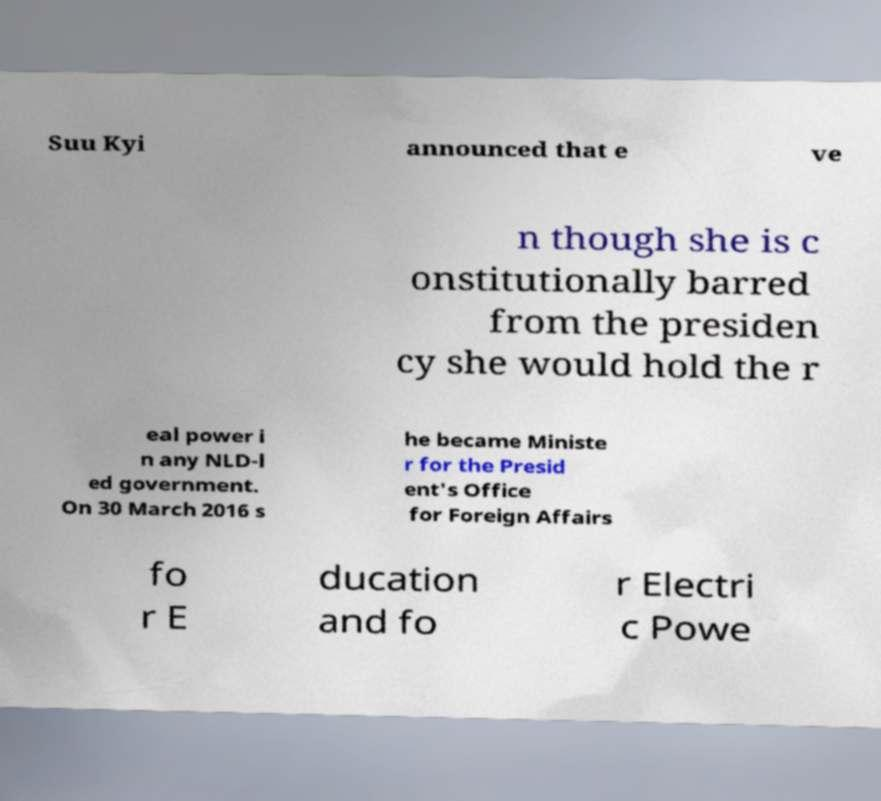Could you assist in decoding the text presented in this image and type it out clearly? Suu Kyi announced that e ve n though she is c onstitutionally barred from the presiden cy she would hold the r eal power i n any NLD-l ed government. On 30 March 2016 s he became Ministe r for the Presid ent's Office for Foreign Affairs fo r E ducation and fo r Electri c Powe 